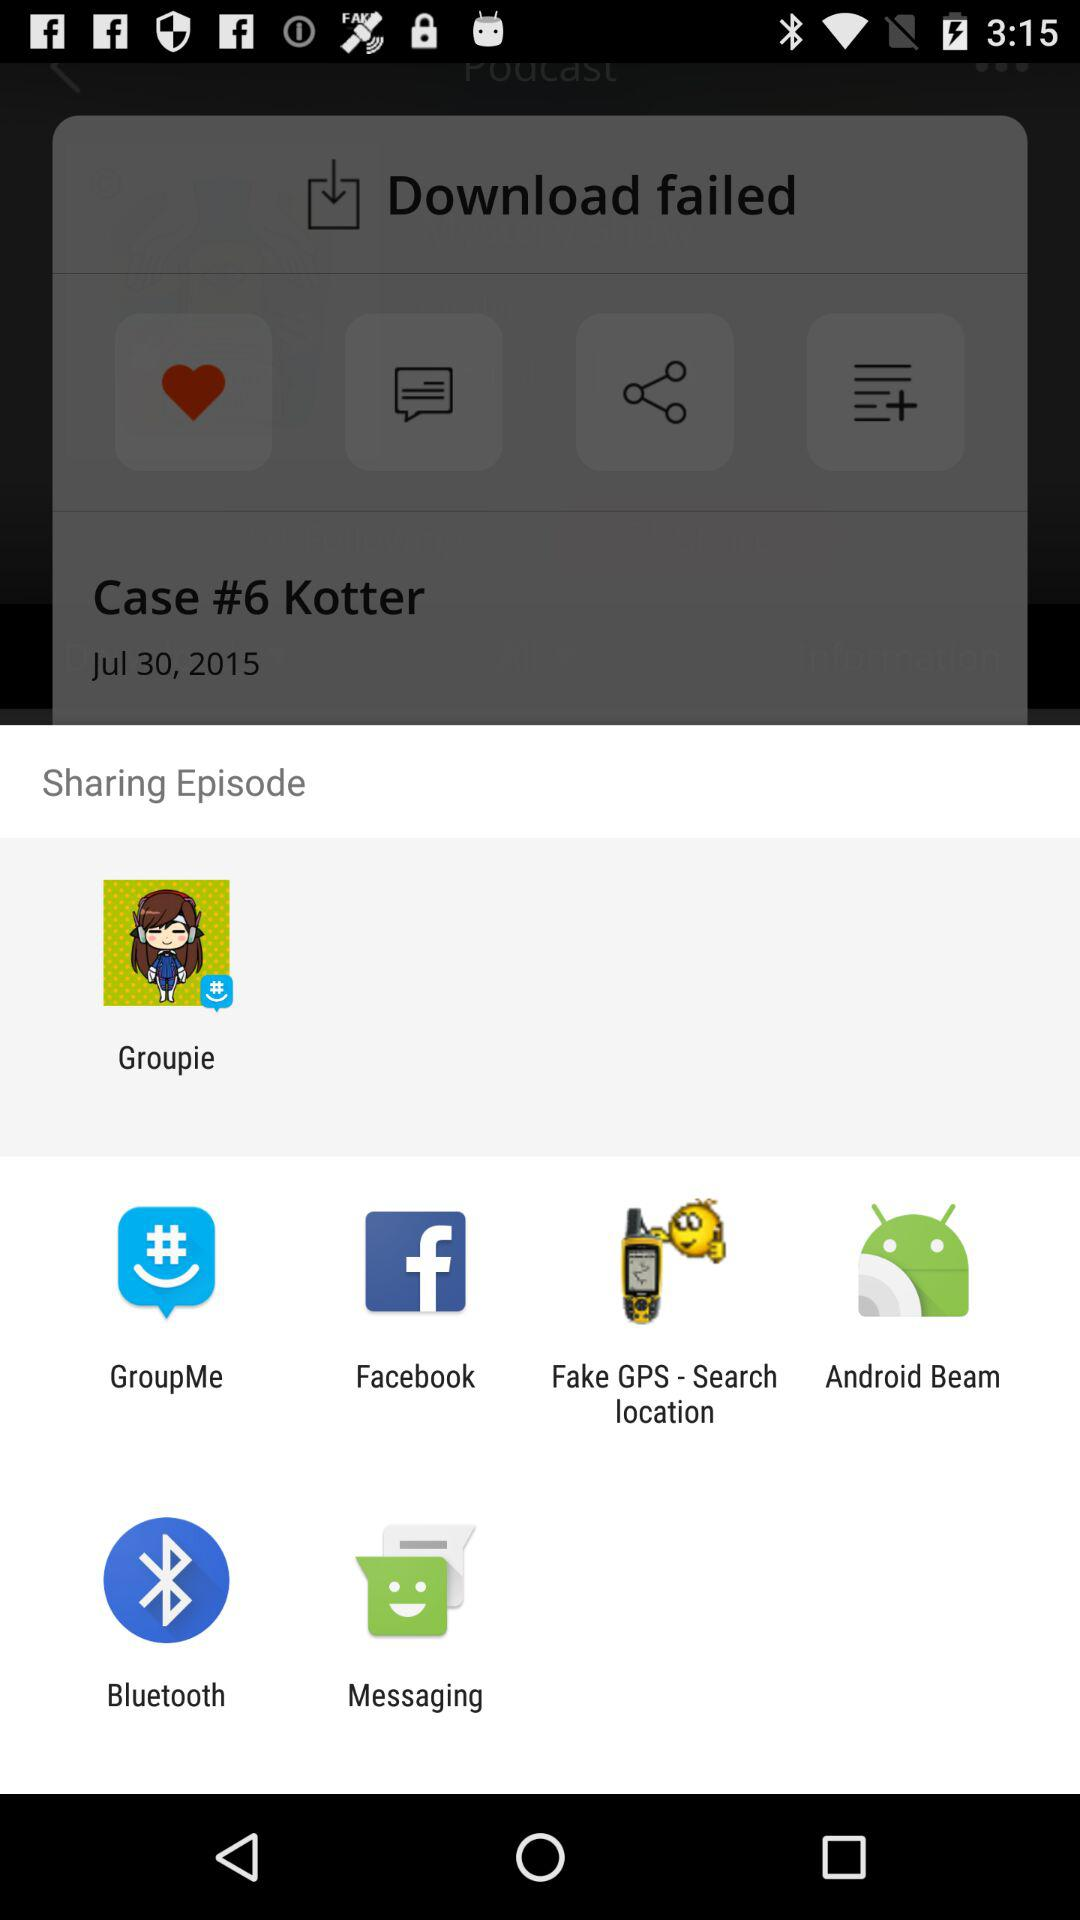What are sharing options? The sharing options are "Groupie", "GroupMe", "Facebook", "Fake GPS - Search location", "Android Beam", "Bluetooth" and "Messaging". 